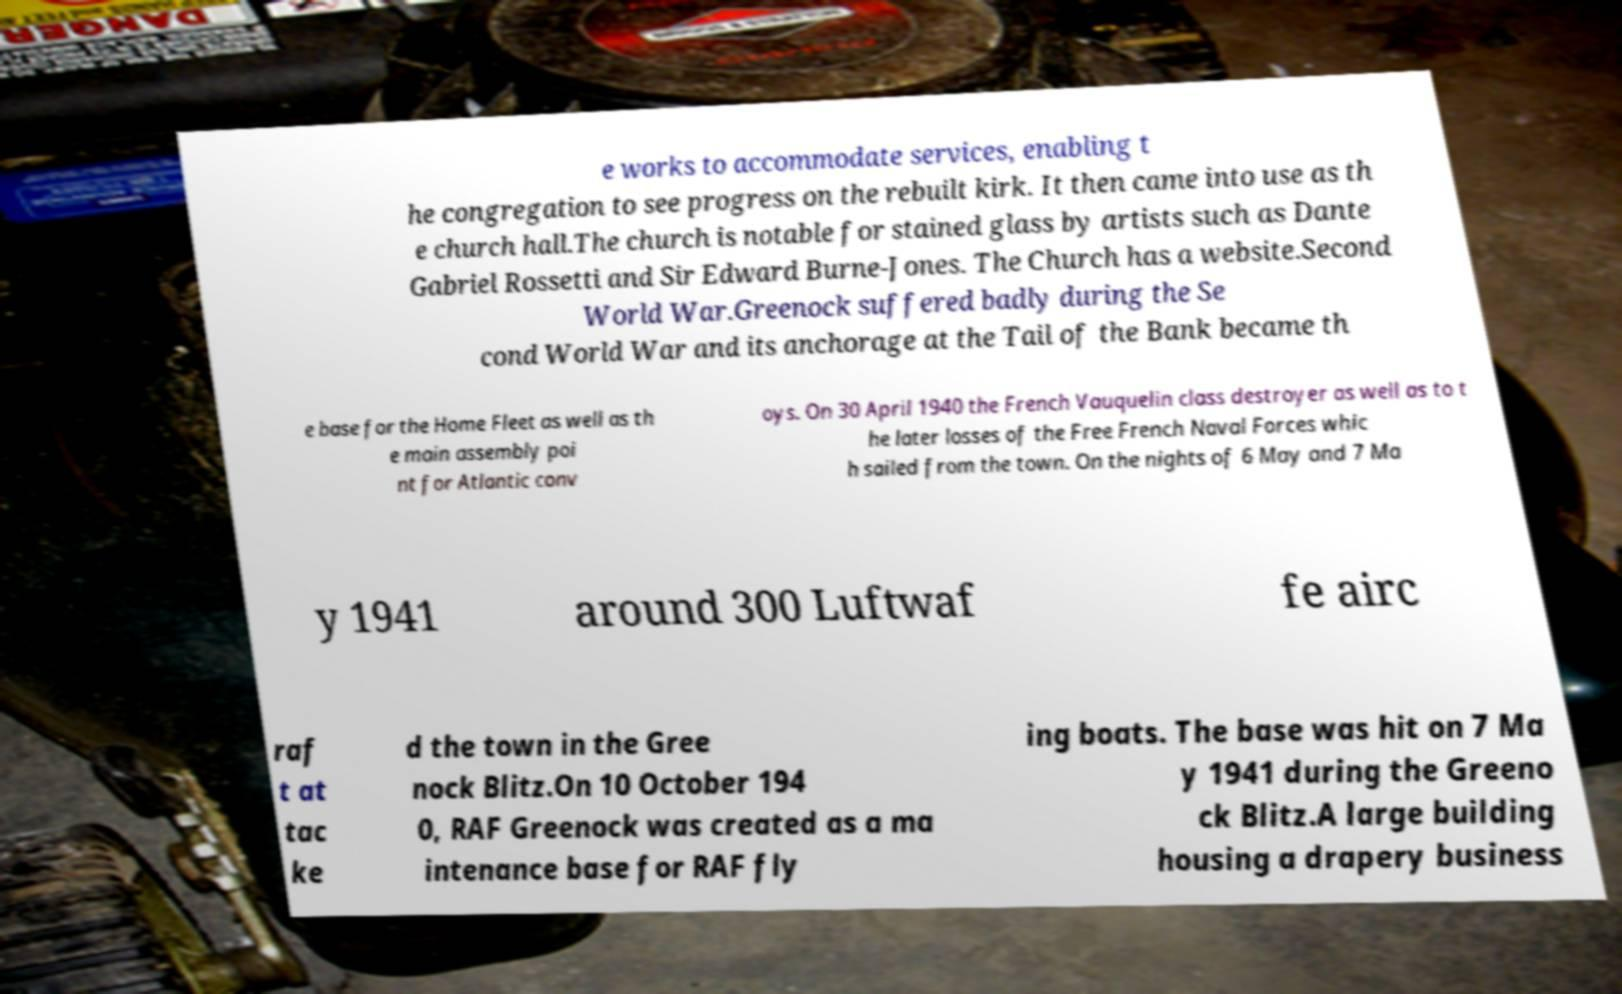Please identify and transcribe the text found in this image. e works to accommodate services, enabling t he congregation to see progress on the rebuilt kirk. It then came into use as th e church hall.The church is notable for stained glass by artists such as Dante Gabriel Rossetti and Sir Edward Burne-Jones. The Church has a website.Second World War.Greenock suffered badly during the Se cond World War and its anchorage at the Tail of the Bank became th e base for the Home Fleet as well as th e main assembly poi nt for Atlantic conv oys. On 30 April 1940 the French Vauquelin class destroyer as well as to t he later losses of the Free French Naval Forces whic h sailed from the town. On the nights of 6 May and 7 Ma y 1941 around 300 Luftwaf fe airc raf t at tac ke d the town in the Gree nock Blitz.On 10 October 194 0, RAF Greenock was created as a ma intenance base for RAF fly ing boats. The base was hit on 7 Ma y 1941 during the Greeno ck Blitz.A large building housing a drapery business 